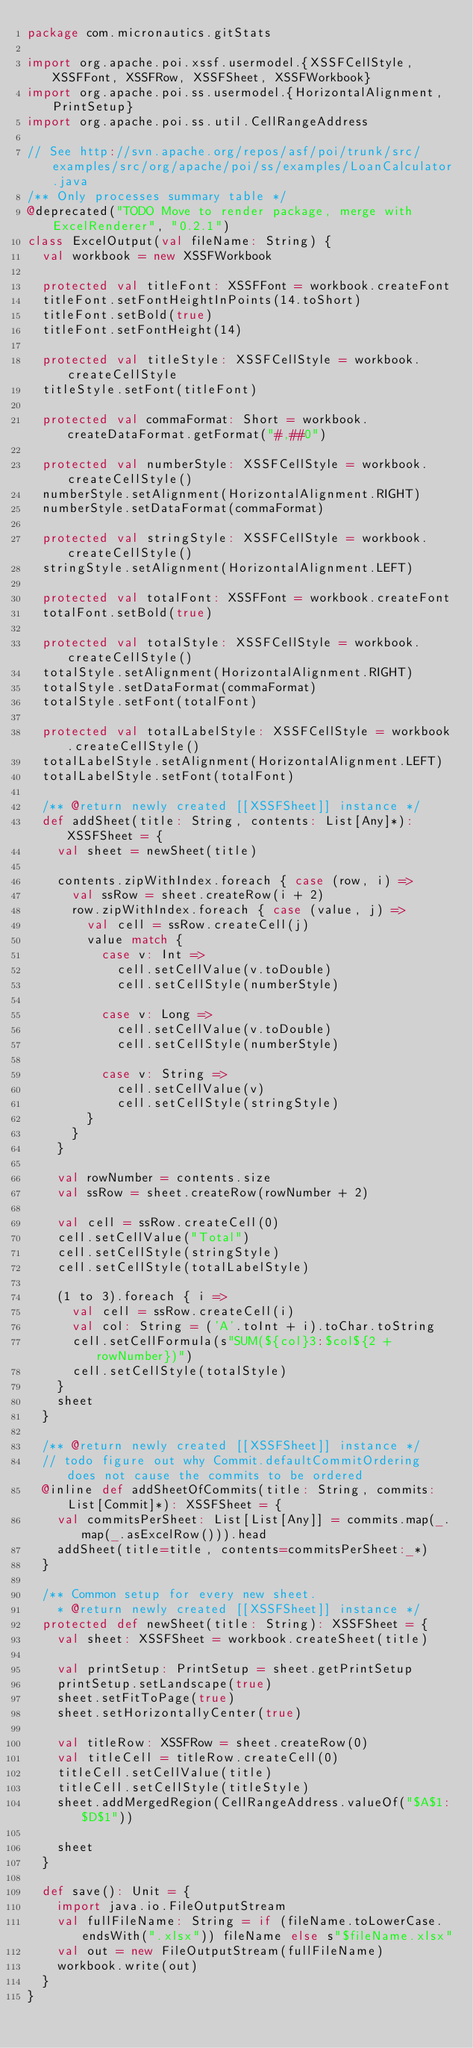Convert code to text. <code><loc_0><loc_0><loc_500><loc_500><_Scala_>package com.micronautics.gitStats

import org.apache.poi.xssf.usermodel.{XSSFCellStyle, XSSFFont, XSSFRow, XSSFSheet, XSSFWorkbook}
import org.apache.poi.ss.usermodel.{HorizontalAlignment, PrintSetup}
import org.apache.poi.ss.util.CellRangeAddress

// See http://svn.apache.org/repos/asf/poi/trunk/src/examples/src/org/apache/poi/ss/examples/LoanCalculator.java
/** Only processes summary table */
@deprecated("TODO Move to render package, merge with ExcelRenderer", "0.2.1")
class ExcelOutput(val fileName: String) {
  val workbook = new XSSFWorkbook

  protected val titleFont: XSSFFont = workbook.createFont
  titleFont.setFontHeightInPoints(14.toShort)
  titleFont.setBold(true)
  titleFont.setFontHeight(14)

  protected val titleStyle: XSSFCellStyle = workbook.createCellStyle
  titleStyle.setFont(titleFont)

  protected val commaFormat: Short = workbook.createDataFormat.getFormat("#,##0")

  protected val numberStyle: XSSFCellStyle = workbook.createCellStyle()
  numberStyle.setAlignment(HorizontalAlignment.RIGHT)
  numberStyle.setDataFormat(commaFormat)

  protected val stringStyle: XSSFCellStyle = workbook.createCellStyle()
  stringStyle.setAlignment(HorizontalAlignment.LEFT)

  protected val totalFont: XSSFFont = workbook.createFont
  totalFont.setBold(true)

  protected val totalStyle: XSSFCellStyle = workbook.createCellStyle()
  totalStyle.setAlignment(HorizontalAlignment.RIGHT)
  totalStyle.setDataFormat(commaFormat)
  totalStyle.setFont(totalFont)

  protected val totalLabelStyle: XSSFCellStyle = workbook.createCellStyle()
  totalLabelStyle.setAlignment(HorizontalAlignment.LEFT)
  totalLabelStyle.setFont(totalFont)

  /** @return newly created [[XSSFSheet]] instance */
  def addSheet(title: String, contents: List[Any]*): XSSFSheet = {
    val sheet = newSheet(title)

    contents.zipWithIndex.foreach { case (row, i) =>
      val ssRow = sheet.createRow(i + 2)
      row.zipWithIndex.foreach { case (value, j) =>
        val cell = ssRow.createCell(j)
        value match {
          case v: Int =>
            cell.setCellValue(v.toDouble)
            cell.setCellStyle(numberStyle)

          case v: Long =>
            cell.setCellValue(v.toDouble)
            cell.setCellStyle(numberStyle)

          case v: String =>
            cell.setCellValue(v)
            cell.setCellStyle(stringStyle)
        }
      }
    }

    val rowNumber = contents.size
    val ssRow = sheet.createRow(rowNumber + 2)

    val cell = ssRow.createCell(0)
    cell.setCellValue("Total")
    cell.setCellStyle(stringStyle)
    cell.setCellStyle(totalLabelStyle)

    (1 to 3).foreach { i =>
      val cell = ssRow.createCell(i)
      val col: String = ('A'.toInt + i).toChar.toString
      cell.setCellFormula(s"SUM(${col}3:$col${2 + rowNumber})")
      cell.setCellStyle(totalStyle)
    }
    sheet
  }

  /** @return newly created [[XSSFSheet]] instance */
  // todo figure out why Commit.defaultCommitOrdering does not cause the commits to be ordered
  @inline def addSheetOfCommits(title: String, commits: List[Commit]*): XSSFSheet = {
    val commitsPerSheet: List[List[Any]] = commits.map(_.map(_.asExcelRow())).head
    addSheet(title=title, contents=commitsPerSheet:_*)
  }

  /** Common setup for every new sheet.
    * @return newly created [[XSSFSheet]] instance */
  protected def newSheet(title: String): XSSFSheet = {
    val sheet: XSSFSheet = workbook.createSheet(title)

    val printSetup: PrintSetup = sheet.getPrintSetup
    printSetup.setLandscape(true)
    sheet.setFitToPage(true)
    sheet.setHorizontallyCenter(true)

    val titleRow: XSSFRow = sheet.createRow(0)
    val titleCell = titleRow.createCell(0)
    titleCell.setCellValue(title)
    titleCell.setCellStyle(titleStyle)
    sheet.addMergedRegion(CellRangeAddress.valueOf("$A$1:$D$1"))

    sheet
  }

  def save(): Unit = {
    import java.io.FileOutputStream
    val fullFileName: String = if (fileName.toLowerCase.endsWith(".xlsx")) fileName else s"$fileName.xlsx"
    val out = new FileOutputStream(fullFileName)
    workbook.write(out)
  }
}
</code> 